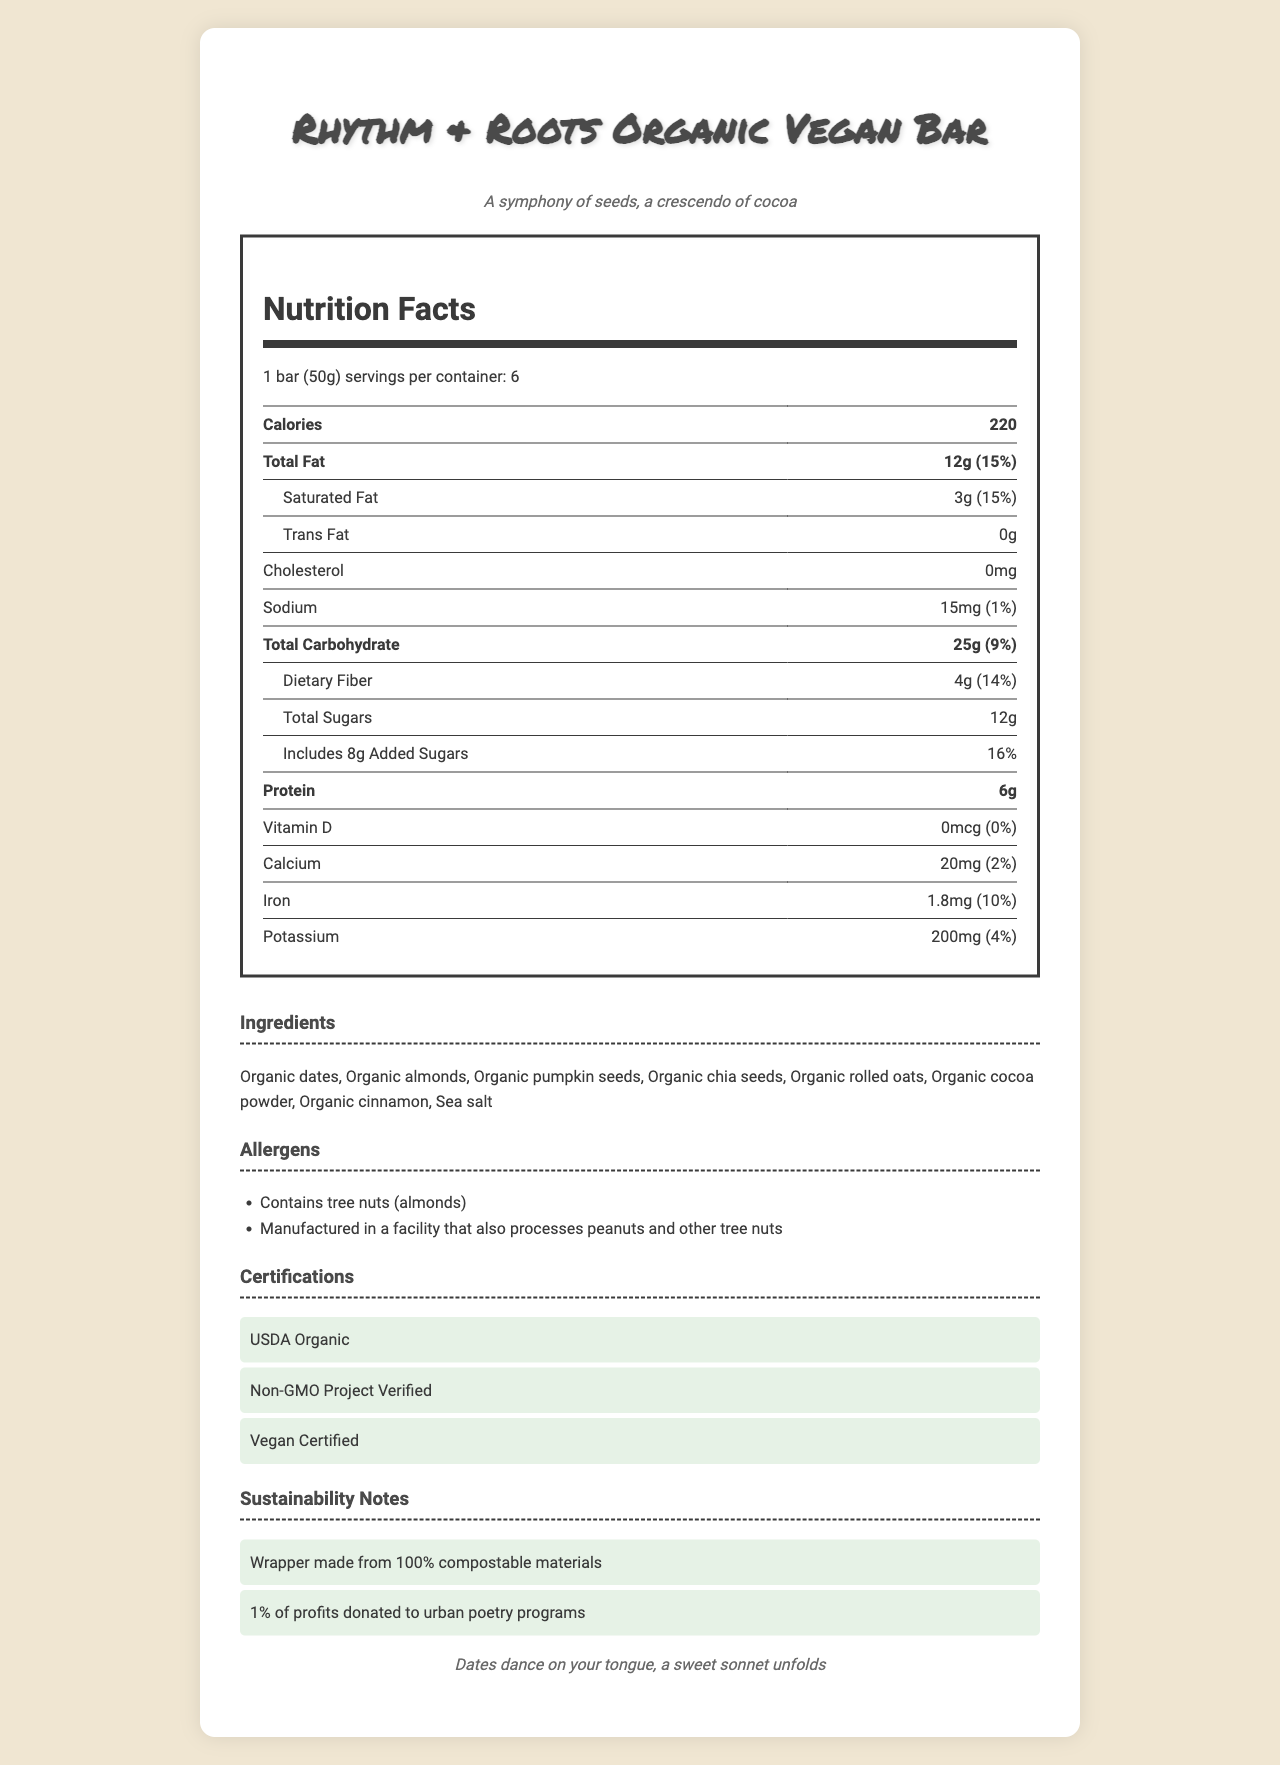What is the serving size of the Rhythm & Roots Organic Vegan Bar? The serving size is specified in the Nutrition Facts section at the beginning of the document.
Answer: 1 bar (50g) How many calories are in one serving of the snack bar? The number of calories per serving is listed in the Nutrition Facts table.
Answer: 220 List the ingredients of the snack bar. The ingredients are provided in the Ingredients section.
Answer: Organic dates, Organic almonds, Organic pumpkin seeds, Organic chia seeds, Organic rolled oats, Organic cocoa powder, Organic cinnamon, Sea salt How much dietary fiber is in each serving? The amount of dietary fiber is listed under Total Carbohydrate in the Nutrition Facts table.
Answer: 4g What certifications does the snack bar have? The certifications are listed in the Certifications section.
Answer: USDA Organic, Non-GMO Project Verified, Vegan Certified Does the snack bar contain any common allergens? The Allergens section mentions that the bar contains tree nuts (almonds) and is manufactured in a facility that processes peanuts and other tree nuts.
Answer: Yes How much iron is in one bar? A. 0.5mg B. 1.5mg C. 1.8mg D. 2.0mg The iron content is listed as 1.8mg in the Nutrition Facts table.
Answer: C Which poetic flavor description is given for cinnamon? A. Symphony of seeds B. A crescendo of cocoa C. Almonds crunch D. Cinnamon whispers secrets The poetic description for cinnamon is "Cinnamon whispers secrets of distant lands".
Answer: D Is there any vitamin D in the snack bar? The Vitamin D amount is listed as 0mcg in the Nutrition Facts table.
Answer: No Describe the main idea of the document. The document combines factual data about the nutritional content and ingredients with poetic descriptions to create an engaging presentation of the snack bar. It also highlights the product's certifications and sustainability contributions to appeal to health-conscious and eco-friendly consumers.
Answer: The document provides detailed nutrition facts, ingredients, allergen information, and poetic flavor descriptions for the Rhythm & Roots Organic Vegan Bar. It highlights the product's certifications and sustainability notes, emphasizing its organic, vegan nature, and commitment to eco-friendly packaging and community support. What percentage of the daily value for calcium does one serving provide? The daily value percentage for calcium is listed in the Nutrition Facts table.
Answer: 2% How many grams of added sugars are in each serving? The amount of added sugars is listed under Total Sugars in the Nutrition Facts table.
Answer: 8g Which ingredient is not present in the snack bar? A. Organic dates B. Organic almonds C. Organic honey D. Sea salt Organic honey is not listed in the Ingredients section.
Answer: C What note is given about the snack bar's packaging? One of the sustainability notes mentions the wrapper's compostable nature.
Answer: Wrapper made from 100% compostable materials How many servings are in one container of the snack bar? The number of servings per container is listed at the beginning of the Nutrition Facts section.
Answer: 6 What does the document say about the bar's contributions to urban poetry programs? The sustainability notes mention that 1% of the bar's profits are donated to urban poetry programs.
Answer: 1% of profits donated to urban poetry programs What is the main source of protein in the nutritional content? The document lists the amount of protein but does not specify the main source of protein in the bar's ingredients.
Answer: Cannot be determined 